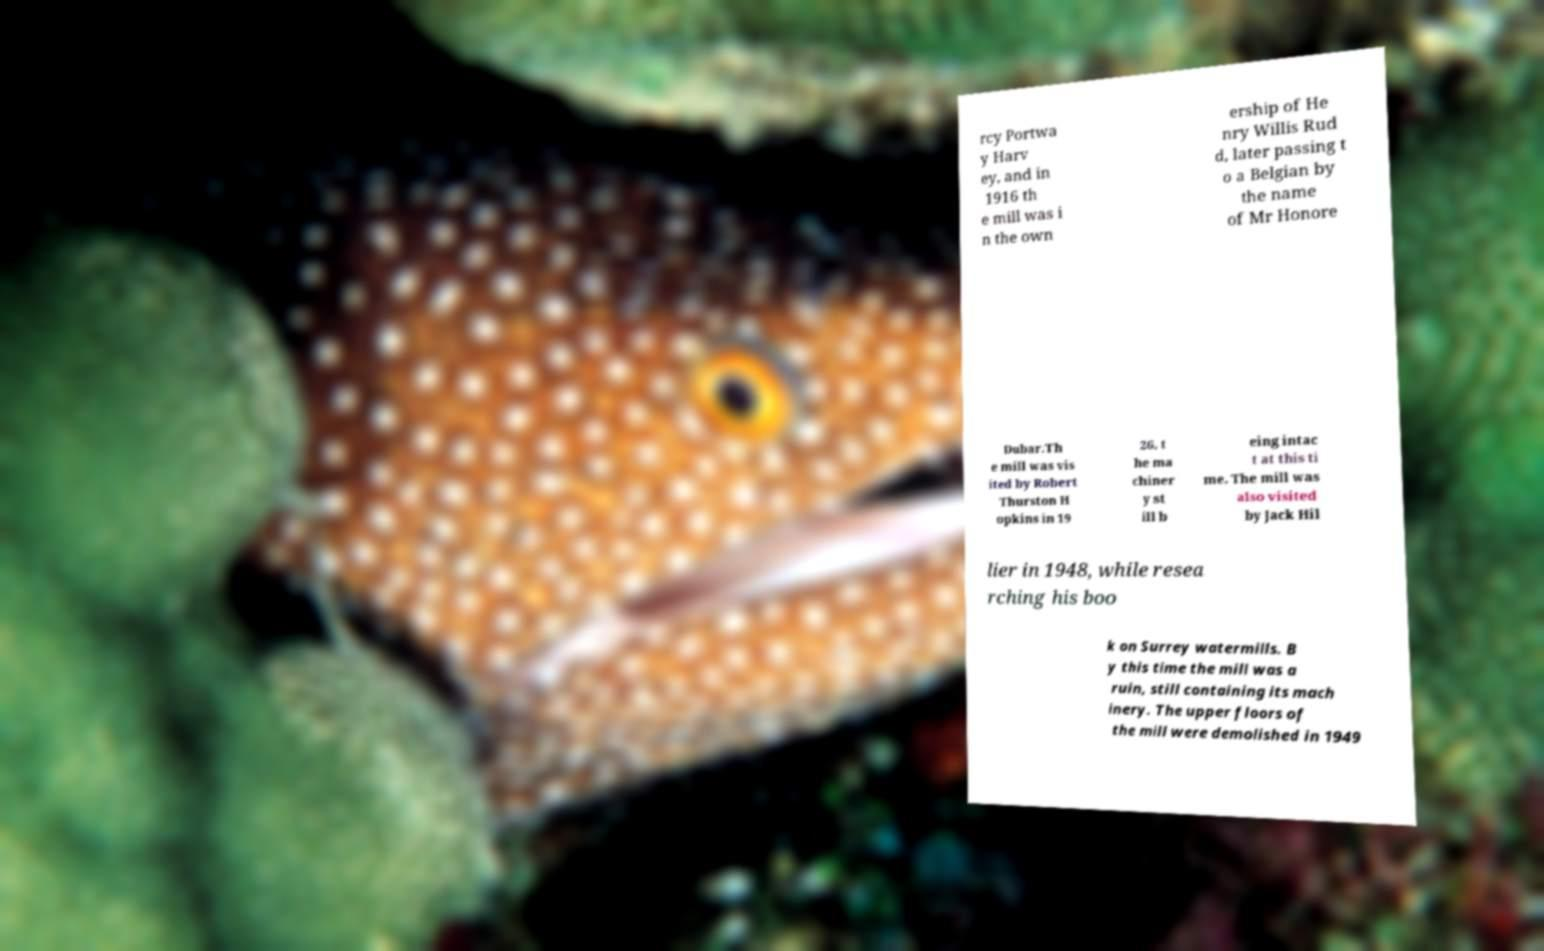Please identify and transcribe the text found in this image. rcy Portwa y Harv ey, and in 1916 th e mill was i n the own ership of He nry Willis Rud d, later passing t o a Belgian by the name of Mr Honore Dubar.Th e mill was vis ited by Robert Thurston H opkins in 19 26, t he ma chiner y st ill b eing intac t at this ti me. The mill was also visited by Jack Hil lier in 1948, while resea rching his boo k on Surrey watermills. B y this time the mill was a ruin, still containing its mach inery. The upper floors of the mill were demolished in 1949 